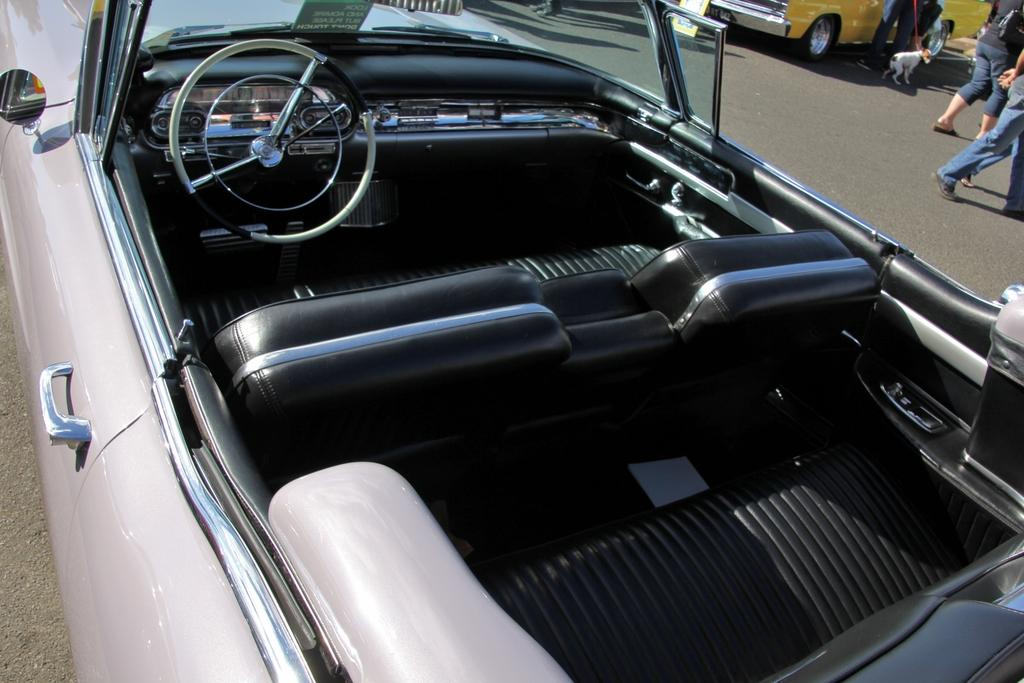What type of car is in the image? There is a topless car in the image. Where is the car located? The car is on the road. What can be seen on the right side of the image? There are people and a dog on the right side of the image. What is the color of the car in the background? There is a yellow color car in the background of the image. What experience does the passenger in the topless car have while driving? There is no information about a passenger in the image, so we cannot determine their experience while driving. 